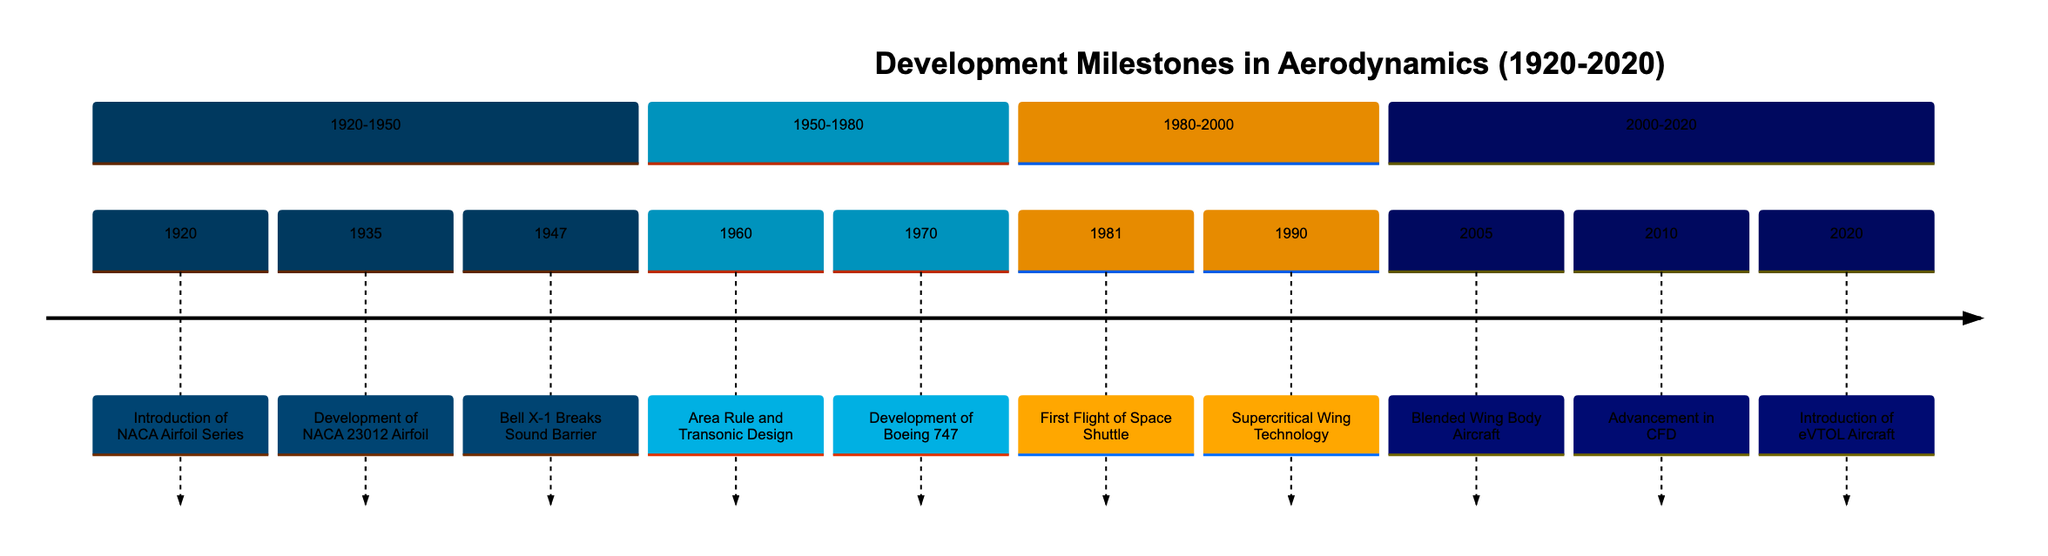What is the first milestone in the timeline? The diagram lists the events chronologically, starting with 1920 as the first year. The achievement in that year is the "Introduction of the NACA Airfoil Series."
Answer: Introduction of the NACA Airfoil Series How many milestones are there between 1950 and 1980? This section of the timeline includes two milestones: "Area Rule and Transonic Design" in 1960 and "Development of Boeing 747" in 1970.
Answer: 2 Which achievement occurred in 1981? The diagram specifies that in 1981, the "First Flight of the Space Shuttle" took place.
Answer: First Flight of Space Shuttle What major aerodynamic advancement was introduced in 2010? The timeline indicates that in 2010, the "Advancement in Computational Fluid Dynamics (CFD)" was achieved, which is a significant milestone.
Answer: Advancement in CFD What relationship exists between the NACA 23012 Airfoil and the Boeing 747? The NACA 23012 Airfoil's development in 1935 can be seen as foundational to modern aerodynamic design principles which are exemplified in the Boeing 747 introduced in 1970, showing the progression of aerodynamic technology over time.
Answer: Foundation to Boeing 747 Which advancement is noted as a key development in hypersonic aerodynamics? The timeline documents that the "First Flight of the Space Shuttle" in 1981 demonstrated reusable spacecraft aerodynamics, which is recognized as a major achievement in hypersonic aerodynamics.
Answer: First Flight of Space Shuttle What year marks the introduction of eVTOL Aircraft? According to the timeline, the introduction of Electric Vertical Takeoff and Landing (eVTOL) Aircraft is marked in the year 2020.
Answer: 2020 Which achievement occurred directly after the Bell X-1 milestone? The timeline shows the chronological order, where "Area Rule and Transonic Design" in 1960 follows the "Bell X-1 Breaks the Sound Barrier" of 1947.
Answer: Area Rule and Transonic Design What is the primary goal of the Blended Wing Body Aircraft developed in 2005? The timeline indicates that the development of the Blended Wing Body Aircraft aimed to improve aerodynamic efficiency and fuel savings in commercial aviation.
Answer: Improved aerodynamic efficiency and fuel savings 